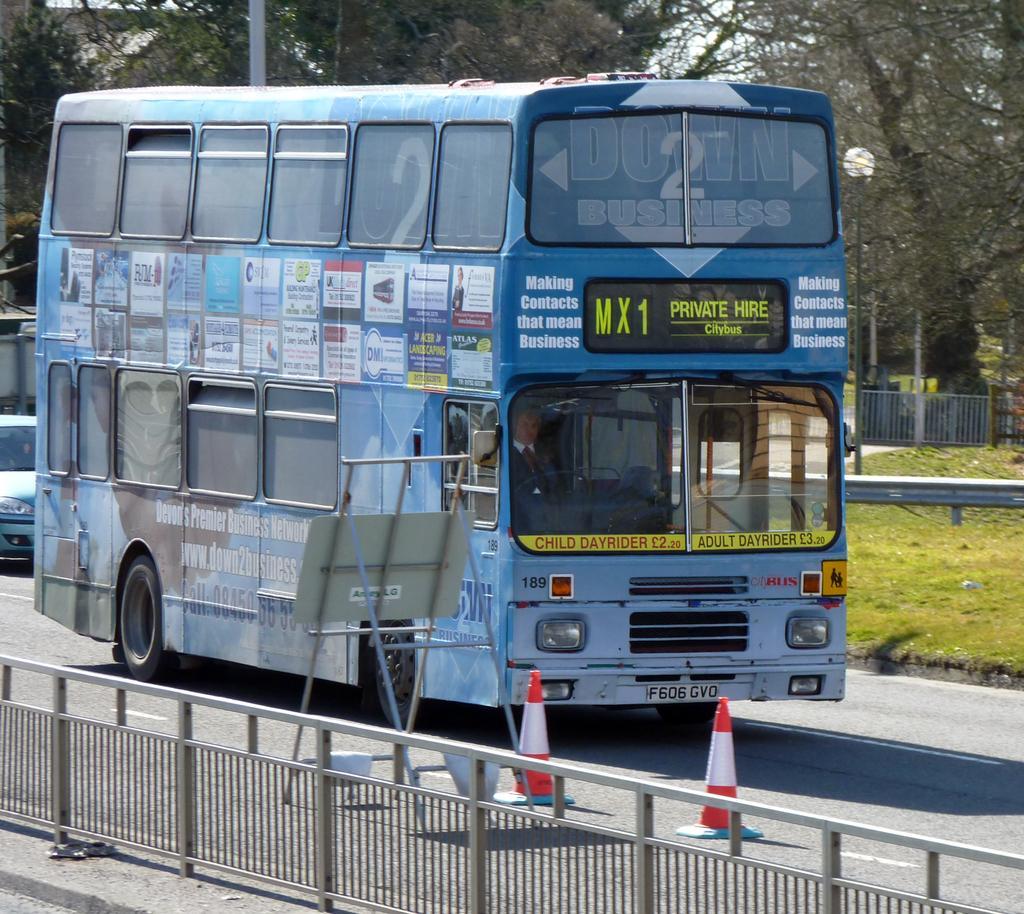Can you describe this image briefly? In the picture a car, a bus on the road, fence, traffic cones, a board and some other objects on the ground. In the background I can see the grass, trees, poles and some other objects. 